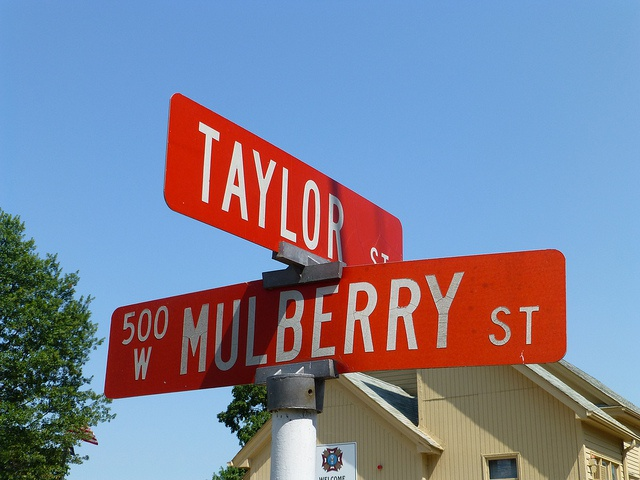Describe the objects in this image and their specific colors. I can see various objects in this image with different colors. 